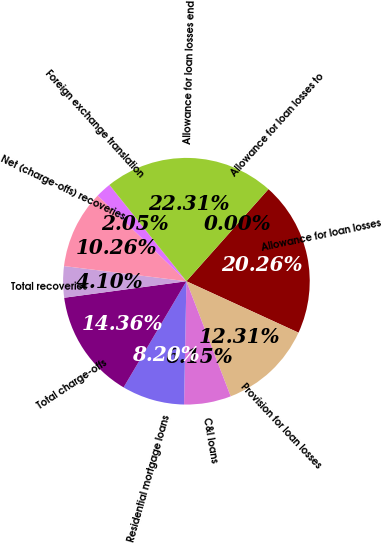Convert chart. <chart><loc_0><loc_0><loc_500><loc_500><pie_chart><fcel>Allowance for loan losses<fcel>Provision for loan losses<fcel>C&I loans<fcel>Residential mortgage loans<fcel>Total charge-offs<fcel>Total recoveries<fcel>Net (charge-offs) recoveries<fcel>Foreign exchange translation<fcel>Allowance for loan losses end<fcel>Allowance for loan losses to<nl><fcel>20.26%<fcel>12.31%<fcel>6.15%<fcel>8.2%<fcel>14.36%<fcel>4.1%<fcel>10.26%<fcel>2.05%<fcel>22.31%<fcel>0.0%<nl></chart> 